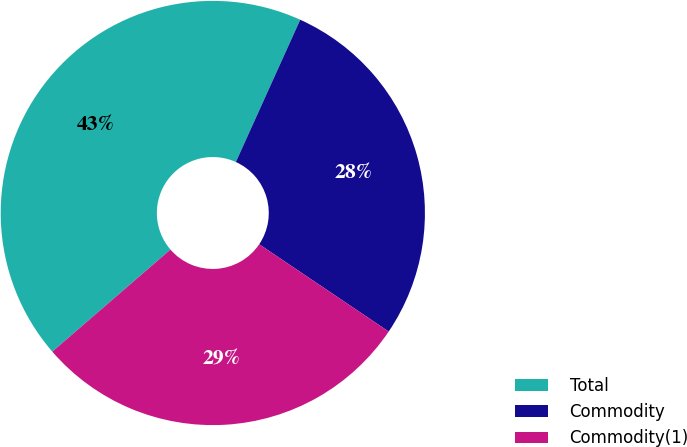Convert chart. <chart><loc_0><loc_0><loc_500><loc_500><pie_chart><fcel>Total<fcel>Commodity<fcel>Commodity(1)<nl><fcel>43.1%<fcel>27.68%<fcel>29.22%<nl></chart> 